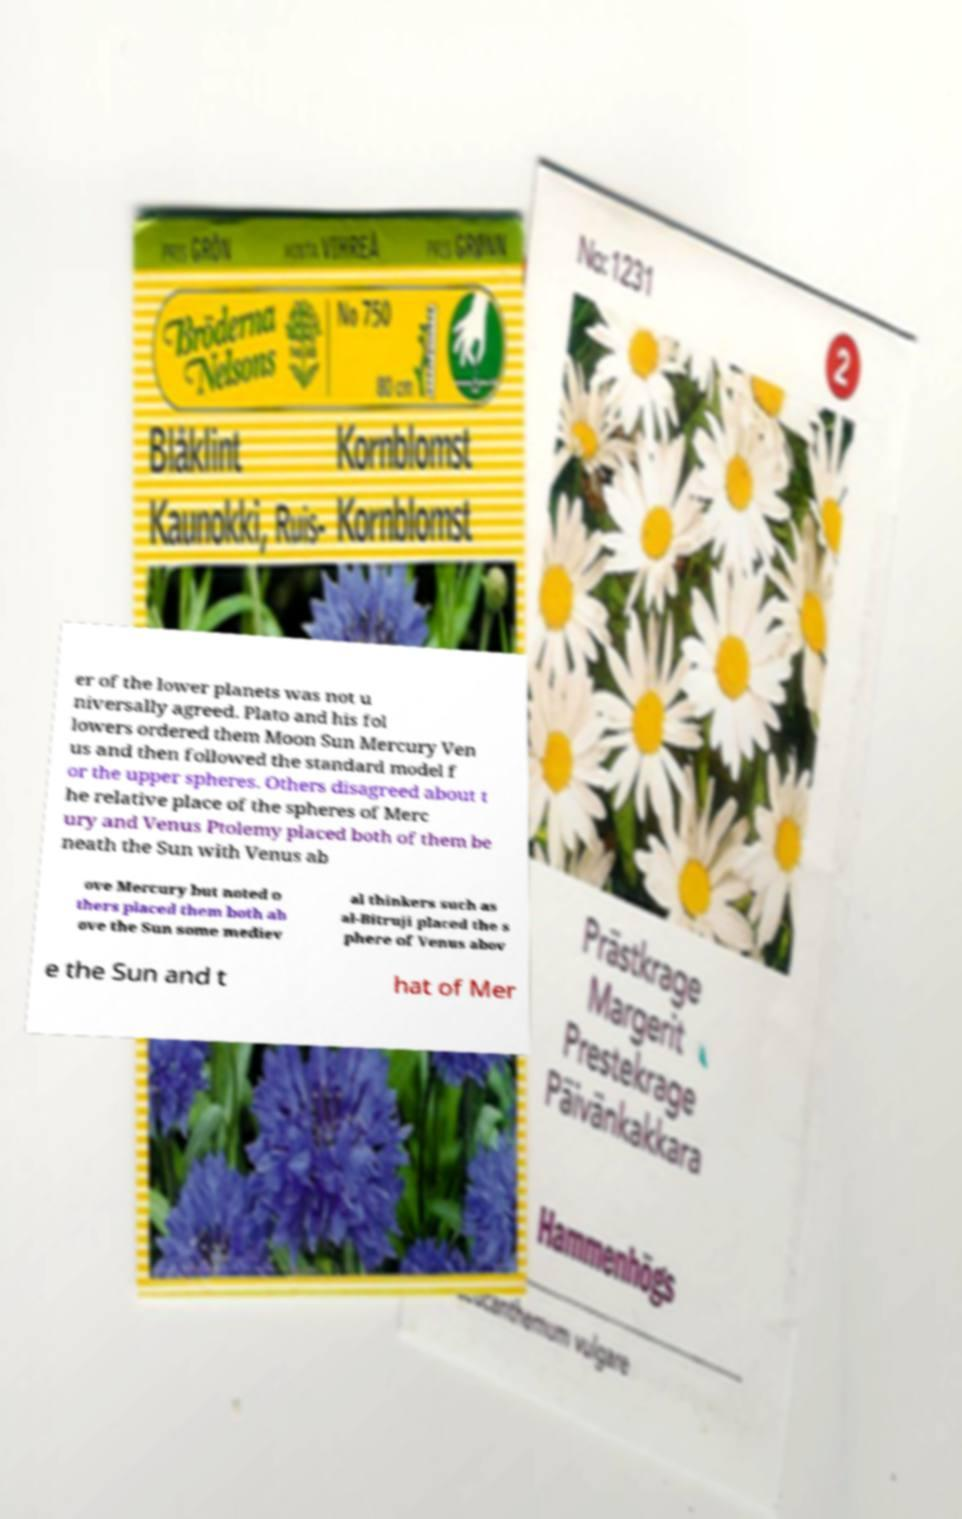I need the written content from this picture converted into text. Can you do that? er of the lower planets was not u niversally agreed. Plato and his fol lowers ordered them Moon Sun Mercury Ven us and then followed the standard model f or the upper spheres. Others disagreed about t he relative place of the spheres of Merc ury and Venus Ptolemy placed both of them be neath the Sun with Venus ab ove Mercury but noted o thers placed them both ab ove the Sun some mediev al thinkers such as al-Bitruji placed the s phere of Venus abov e the Sun and t hat of Mer 